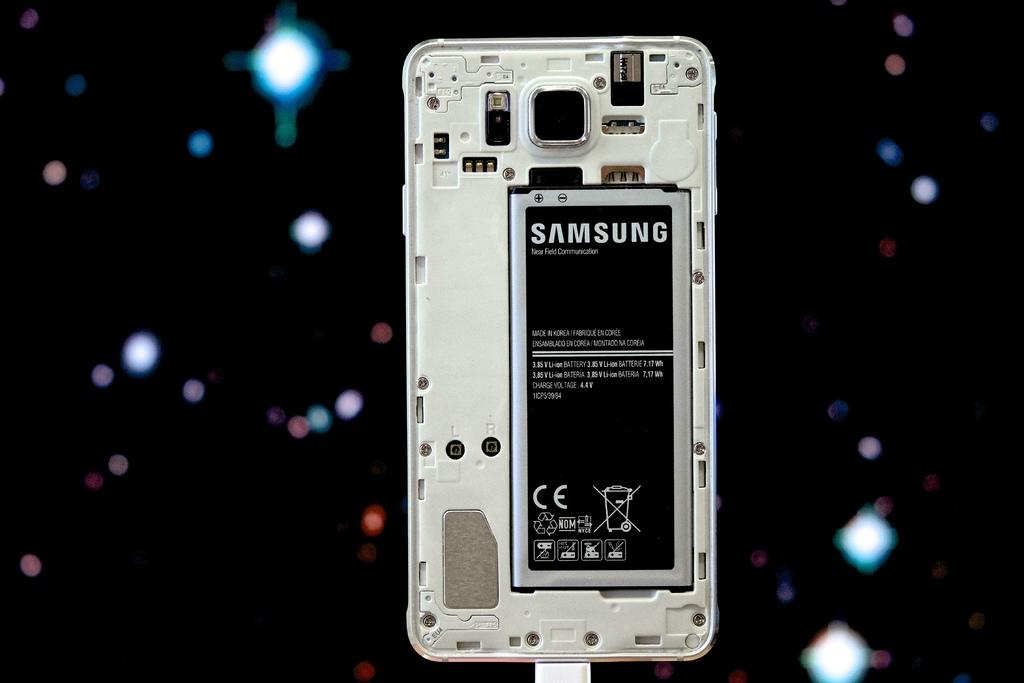<image>
Describe the image concisely. The exposed back of a samsung branded phone showing its battery. 